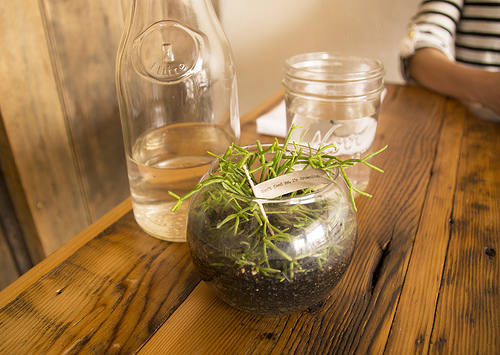<image>
Is there a plant on the glass? Yes. Looking at the image, I can see the plant is positioned on top of the glass, with the glass providing support. 